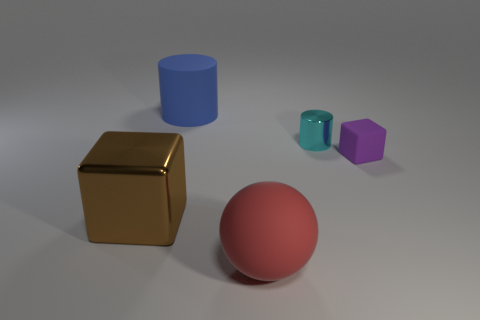What might be the purpose of arranging these objects like this? This arrangement of objects may serve several purposes. It could be part of a 3D rendering test to evaluate the visual effects of different materials, shapes, and shadows. Alternatively, it might be used in an art or design context to study color interaction, composition, and form. Or it could simply be a creative display to showcase these qualities in a visually appealing manner. 